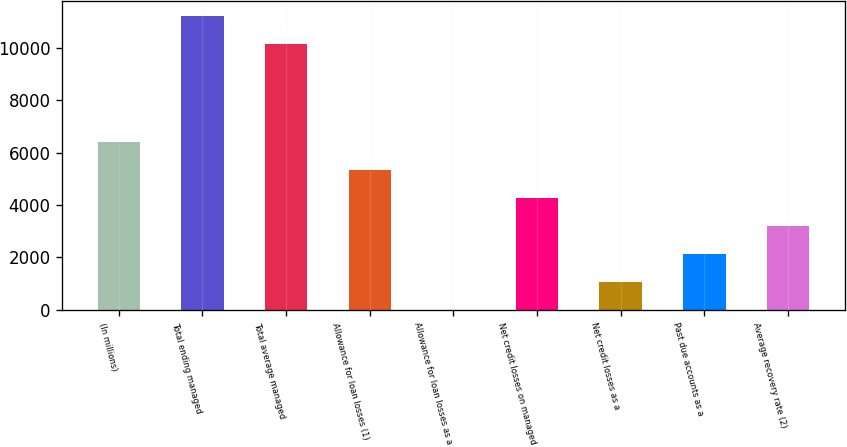Convert chart to OTSL. <chart><loc_0><loc_0><loc_500><loc_500><bar_chart><fcel>(In millions)<fcel>Total ending managed<fcel>Total average managed<fcel>Allowance for loan losses (1)<fcel>Allowance for loan losses as a<fcel>Net credit losses on managed<fcel>Net credit losses as a<fcel>Past due accounts as a<fcel>Average recovery rate (2)<nl><fcel>6409.22<fcel>11226.3<fcel>10158.3<fcel>5341.21<fcel>1.16<fcel>4273.2<fcel>1069.17<fcel>2137.18<fcel>3205.19<nl></chart> 